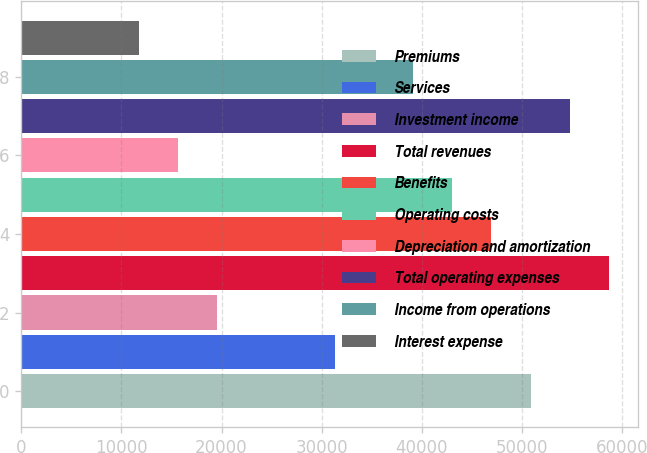Convert chart to OTSL. <chart><loc_0><loc_0><loc_500><loc_500><bar_chart><fcel>Premiums<fcel>Services<fcel>Investment income<fcel>Total revenues<fcel>Benefits<fcel>Operating costs<fcel>Depreciation and amortization<fcel>Total operating expenses<fcel>Income from operations<fcel>Interest expense<nl><fcel>50863.5<fcel>31301<fcel>19563.5<fcel>58688.5<fcel>46951<fcel>43038.5<fcel>15651<fcel>54776<fcel>39126<fcel>11738.5<nl></chart> 